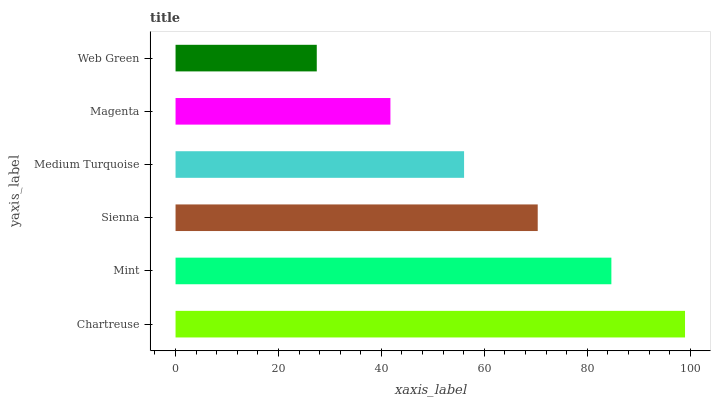Is Web Green the minimum?
Answer yes or no. Yes. Is Chartreuse the maximum?
Answer yes or no. Yes. Is Mint the minimum?
Answer yes or no. No. Is Mint the maximum?
Answer yes or no. No. Is Chartreuse greater than Mint?
Answer yes or no. Yes. Is Mint less than Chartreuse?
Answer yes or no. Yes. Is Mint greater than Chartreuse?
Answer yes or no. No. Is Chartreuse less than Mint?
Answer yes or no. No. Is Sienna the high median?
Answer yes or no. Yes. Is Medium Turquoise the low median?
Answer yes or no. Yes. Is Web Green the high median?
Answer yes or no. No. Is Web Green the low median?
Answer yes or no. No. 